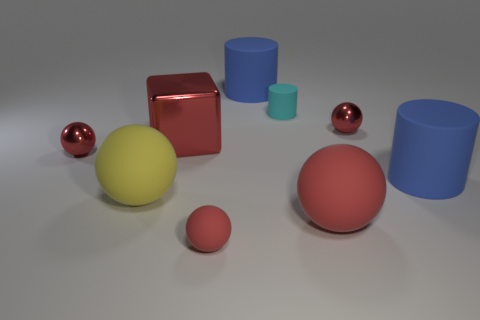Does the large block have the same material as the tiny ball in front of the yellow matte sphere?
Offer a very short reply. No. What is the color of the shiny block?
Ensure brevity in your answer.  Red. What color is the large matte object behind the shiny sphere right of the large blue rubber thing that is behind the cyan matte thing?
Make the answer very short. Blue. Does the big yellow object have the same shape as the large blue matte thing that is to the right of the small matte cylinder?
Your answer should be compact. No. There is a object that is behind the large red block and right of the large red matte ball; what color is it?
Your response must be concise. Red. Are there any other small cyan objects that have the same shape as the cyan rubber thing?
Provide a short and direct response. No. Is the large shiny cube the same color as the small cylinder?
Your answer should be very brief. No. Are there any small cyan rubber objects to the left of the tiny metallic thing that is left of the cyan thing?
Ensure brevity in your answer.  No. How many things are large rubber balls that are right of the tiny red matte thing or blue cylinders left of the tiny rubber cylinder?
Provide a succinct answer. 2. What number of objects are red balls or red things that are behind the big red metal block?
Offer a terse response. 4. 